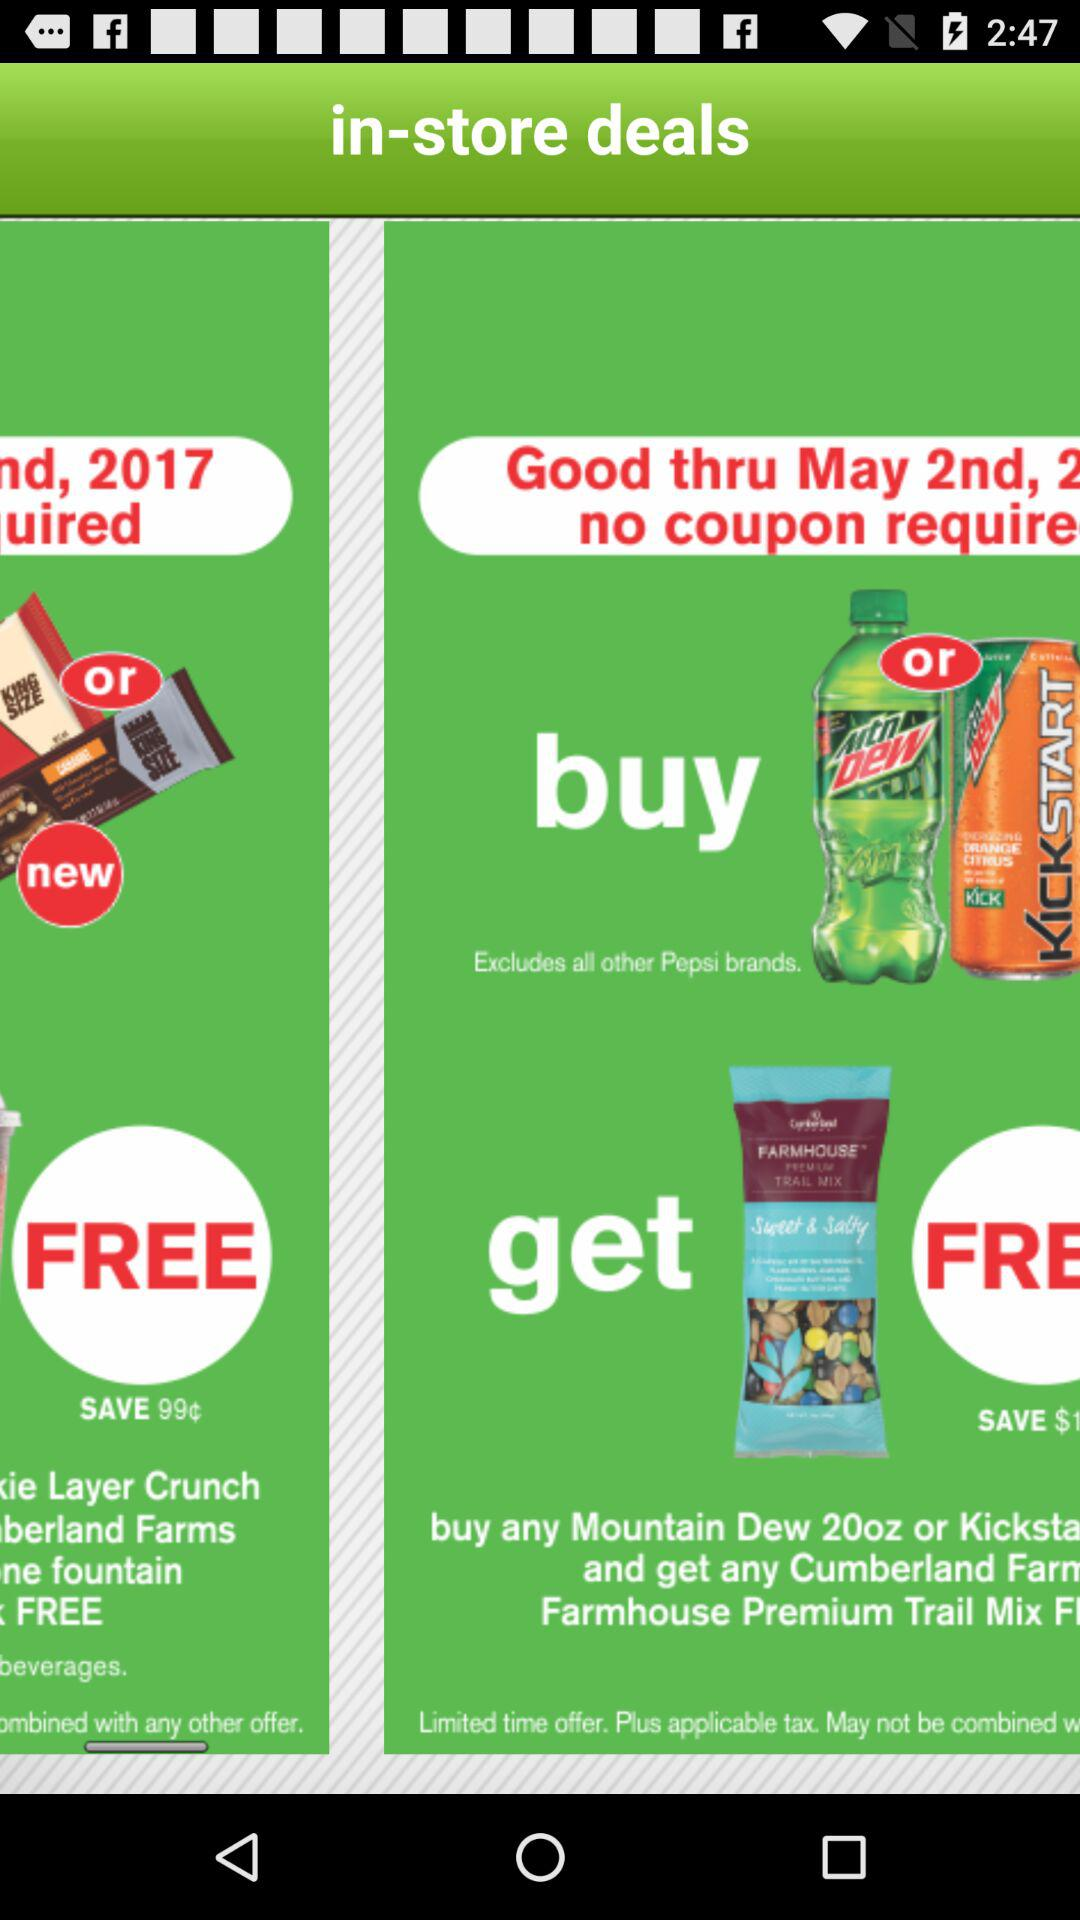On what date are these deals in the store? These deals are in the store on May 2nd, 2017. 